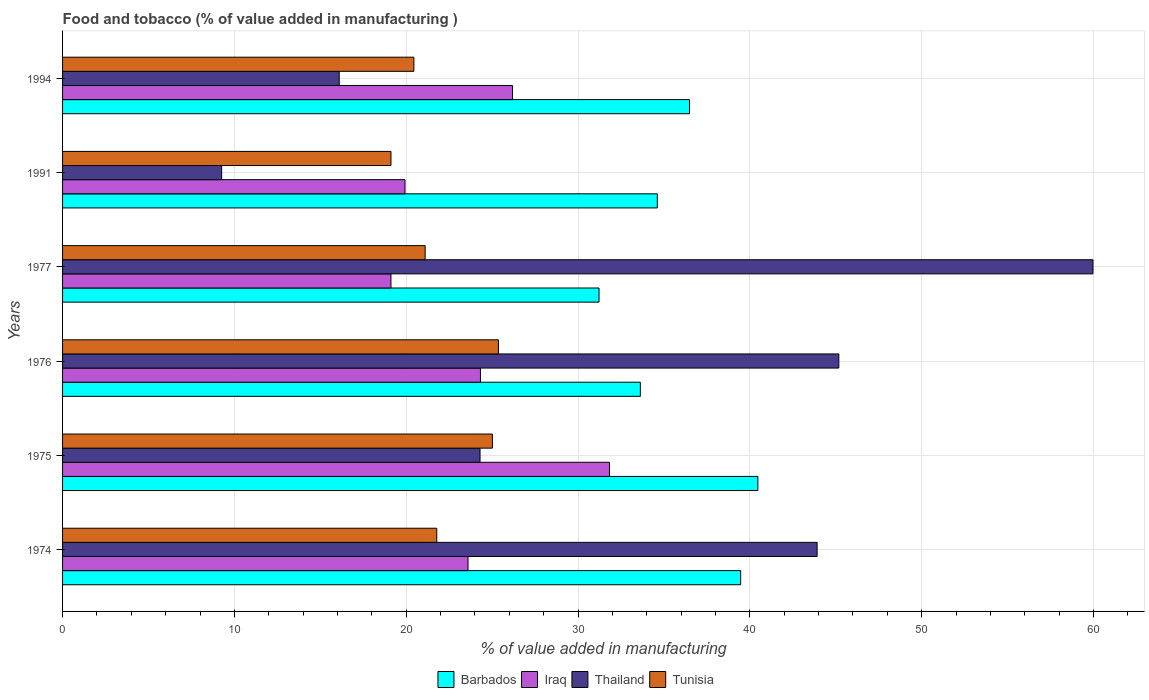How many groups of bars are there?
Offer a very short reply. 6. Are the number of bars per tick equal to the number of legend labels?
Give a very brief answer. Yes. How many bars are there on the 2nd tick from the bottom?
Ensure brevity in your answer.  4. In how many cases, is the number of bars for a given year not equal to the number of legend labels?
Ensure brevity in your answer.  0. What is the value added in manufacturing food and tobacco in Thailand in 1974?
Provide a short and direct response. 43.91. Across all years, what is the maximum value added in manufacturing food and tobacco in Tunisia?
Give a very brief answer. 25.37. Across all years, what is the minimum value added in manufacturing food and tobacco in Iraq?
Your answer should be compact. 19.11. In which year was the value added in manufacturing food and tobacco in Iraq maximum?
Provide a short and direct response. 1975. What is the total value added in manufacturing food and tobacco in Barbados in the graph?
Make the answer very short. 215.87. What is the difference between the value added in manufacturing food and tobacco in Iraq in 1976 and that in 1977?
Offer a terse response. 5.21. What is the difference between the value added in manufacturing food and tobacco in Tunisia in 1976 and the value added in manufacturing food and tobacco in Iraq in 1974?
Offer a terse response. 1.77. What is the average value added in manufacturing food and tobacco in Tunisia per year?
Your answer should be compact. 22.14. In the year 1976, what is the difference between the value added in manufacturing food and tobacco in Tunisia and value added in manufacturing food and tobacco in Thailand?
Provide a short and direct response. -19.81. In how many years, is the value added in manufacturing food and tobacco in Thailand greater than 8 %?
Ensure brevity in your answer.  6. What is the ratio of the value added in manufacturing food and tobacco in Iraq in 1976 to that in 1994?
Ensure brevity in your answer.  0.93. Is the value added in manufacturing food and tobacco in Thailand in 1974 less than that in 1991?
Provide a succinct answer. No. What is the difference between the highest and the second highest value added in manufacturing food and tobacco in Iraq?
Make the answer very short. 5.65. What is the difference between the highest and the lowest value added in manufacturing food and tobacco in Iraq?
Provide a succinct answer. 12.72. In how many years, is the value added in manufacturing food and tobacco in Thailand greater than the average value added in manufacturing food and tobacco in Thailand taken over all years?
Your answer should be very brief. 3. What does the 4th bar from the top in 1977 represents?
Make the answer very short. Barbados. What does the 2nd bar from the bottom in 1974 represents?
Make the answer very short. Iraq. How many years are there in the graph?
Your answer should be compact. 6. What is the difference between two consecutive major ticks on the X-axis?
Your answer should be compact. 10. Are the values on the major ticks of X-axis written in scientific E-notation?
Your answer should be compact. No. Does the graph contain any zero values?
Provide a short and direct response. No. Where does the legend appear in the graph?
Make the answer very short. Bottom center. What is the title of the graph?
Give a very brief answer. Food and tobacco (% of value added in manufacturing ). What is the label or title of the X-axis?
Offer a terse response. % of value added in manufacturing. What is the label or title of the Y-axis?
Give a very brief answer. Years. What is the % of value added in manufacturing in Barbados in 1974?
Keep it short and to the point. 39.46. What is the % of value added in manufacturing of Iraq in 1974?
Your answer should be compact. 23.6. What is the % of value added in manufacturing of Thailand in 1974?
Make the answer very short. 43.91. What is the % of value added in manufacturing of Tunisia in 1974?
Make the answer very short. 21.78. What is the % of value added in manufacturing of Barbados in 1975?
Your answer should be compact. 40.46. What is the % of value added in manufacturing in Iraq in 1975?
Provide a succinct answer. 31.83. What is the % of value added in manufacturing in Thailand in 1975?
Provide a succinct answer. 24.3. What is the % of value added in manufacturing of Tunisia in 1975?
Your answer should be very brief. 25.01. What is the % of value added in manufacturing in Barbados in 1976?
Provide a succinct answer. 33.63. What is the % of value added in manufacturing in Iraq in 1976?
Ensure brevity in your answer.  24.32. What is the % of value added in manufacturing of Thailand in 1976?
Give a very brief answer. 45.17. What is the % of value added in manufacturing in Tunisia in 1976?
Give a very brief answer. 25.37. What is the % of value added in manufacturing of Barbados in 1977?
Provide a succinct answer. 31.22. What is the % of value added in manufacturing of Iraq in 1977?
Your answer should be compact. 19.11. What is the % of value added in manufacturing of Thailand in 1977?
Your answer should be very brief. 59.97. What is the % of value added in manufacturing in Tunisia in 1977?
Keep it short and to the point. 21.1. What is the % of value added in manufacturing in Barbados in 1991?
Give a very brief answer. 34.61. What is the % of value added in manufacturing in Iraq in 1991?
Provide a short and direct response. 19.93. What is the % of value added in manufacturing of Thailand in 1991?
Keep it short and to the point. 9.26. What is the % of value added in manufacturing in Tunisia in 1991?
Keep it short and to the point. 19.11. What is the % of value added in manufacturing of Barbados in 1994?
Give a very brief answer. 36.49. What is the % of value added in manufacturing in Iraq in 1994?
Your answer should be very brief. 26.19. What is the % of value added in manufacturing in Thailand in 1994?
Give a very brief answer. 16.1. What is the % of value added in manufacturing in Tunisia in 1994?
Provide a succinct answer. 20.45. Across all years, what is the maximum % of value added in manufacturing in Barbados?
Provide a short and direct response. 40.46. Across all years, what is the maximum % of value added in manufacturing in Iraq?
Make the answer very short. 31.83. Across all years, what is the maximum % of value added in manufacturing in Thailand?
Ensure brevity in your answer.  59.97. Across all years, what is the maximum % of value added in manufacturing of Tunisia?
Provide a short and direct response. 25.37. Across all years, what is the minimum % of value added in manufacturing in Barbados?
Your answer should be compact. 31.22. Across all years, what is the minimum % of value added in manufacturing in Iraq?
Your answer should be compact. 19.11. Across all years, what is the minimum % of value added in manufacturing of Thailand?
Provide a short and direct response. 9.26. Across all years, what is the minimum % of value added in manufacturing in Tunisia?
Your answer should be compact. 19.11. What is the total % of value added in manufacturing in Barbados in the graph?
Your answer should be compact. 215.87. What is the total % of value added in manufacturing of Iraq in the graph?
Your answer should be very brief. 144.97. What is the total % of value added in manufacturing in Thailand in the graph?
Make the answer very short. 198.71. What is the total % of value added in manufacturing in Tunisia in the graph?
Offer a very short reply. 132.82. What is the difference between the % of value added in manufacturing in Barbados in 1974 and that in 1975?
Provide a succinct answer. -1. What is the difference between the % of value added in manufacturing in Iraq in 1974 and that in 1975?
Give a very brief answer. -8.24. What is the difference between the % of value added in manufacturing of Thailand in 1974 and that in 1975?
Your answer should be compact. 19.62. What is the difference between the % of value added in manufacturing in Tunisia in 1974 and that in 1975?
Provide a succinct answer. -3.24. What is the difference between the % of value added in manufacturing in Barbados in 1974 and that in 1976?
Provide a succinct answer. 5.84. What is the difference between the % of value added in manufacturing of Iraq in 1974 and that in 1976?
Offer a terse response. -0.72. What is the difference between the % of value added in manufacturing in Thailand in 1974 and that in 1976?
Provide a succinct answer. -1.26. What is the difference between the % of value added in manufacturing in Tunisia in 1974 and that in 1976?
Provide a succinct answer. -3.59. What is the difference between the % of value added in manufacturing of Barbados in 1974 and that in 1977?
Keep it short and to the point. 8.24. What is the difference between the % of value added in manufacturing in Iraq in 1974 and that in 1977?
Provide a succinct answer. 4.49. What is the difference between the % of value added in manufacturing in Thailand in 1974 and that in 1977?
Ensure brevity in your answer.  -16.05. What is the difference between the % of value added in manufacturing of Tunisia in 1974 and that in 1977?
Your answer should be very brief. 0.68. What is the difference between the % of value added in manufacturing of Barbados in 1974 and that in 1991?
Ensure brevity in your answer.  4.85. What is the difference between the % of value added in manufacturing in Iraq in 1974 and that in 1991?
Give a very brief answer. 3.67. What is the difference between the % of value added in manufacturing of Thailand in 1974 and that in 1991?
Make the answer very short. 34.65. What is the difference between the % of value added in manufacturing in Tunisia in 1974 and that in 1991?
Make the answer very short. 2.66. What is the difference between the % of value added in manufacturing in Barbados in 1974 and that in 1994?
Provide a succinct answer. 2.98. What is the difference between the % of value added in manufacturing of Iraq in 1974 and that in 1994?
Offer a very short reply. -2.59. What is the difference between the % of value added in manufacturing of Thailand in 1974 and that in 1994?
Give a very brief answer. 27.81. What is the difference between the % of value added in manufacturing in Tunisia in 1974 and that in 1994?
Give a very brief answer. 1.33. What is the difference between the % of value added in manufacturing in Barbados in 1975 and that in 1976?
Your answer should be very brief. 6.84. What is the difference between the % of value added in manufacturing of Iraq in 1975 and that in 1976?
Ensure brevity in your answer.  7.51. What is the difference between the % of value added in manufacturing in Thailand in 1975 and that in 1976?
Offer a terse response. -20.88. What is the difference between the % of value added in manufacturing of Tunisia in 1975 and that in 1976?
Keep it short and to the point. -0.35. What is the difference between the % of value added in manufacturing of Barbados in 1975 and that in 1977?
Keep it short and to the point. 9.24. What is the difference between the % of value added in manufacturing in Iraq in 1975 and that in 1977?
Provide a short and direct response. 12.72. What is the difference between the % of value added in manufacturing in Thailand in 1975 and that in 1977?
Make the answer very short. -35.67. What is the difference between the % of value added in manufacturing of Tunisia in 1975 and that in 1977?
Provide a succinct answer. 3.91. What is the difference between the % of value added in manufacturing in Barbados in 1975 and that in 1991?
Provide a short and direct response. 5.85. What is the difference between the % of value added in manufacturing in Iraq in 1975 and that in 1991?
Your answer should be compact. 11.9. What is the difference between the % of value added in manufacturing in Thailand in 1975 and that in 1991?
Provide a short and direct response. 15.04. What is the difference between the % of value added in manufacturing of Tunisia in 1975 and that in 1991?
Offer a very short reply. 5.9. What is the difference between the % of value added in manufacturing in Barbados in 1975 and that in 1994?
Provide a short and direct response. 3.98. What is the difference between the % of value added in manufacturing in Iraq in 1975 and that in 1994?
Offer a terse response. 5.65. What is the difference between the % of value added in manufacturing of Thailand in 1975 and that in 1994?
Your answer should be compact. 8.19. What is the difference between the % of value added in manufacturing in Tunisia in 1975 and that in 1994?
Keep it short and to the point. 4.57. What is the difference between the % of value added in manufacturing of Barbados in 1976 and that in 1977?
Give a very brief answer. 2.41. What is the difference between the % of value added in manufacturing in Iraq in 1976 and that in 1977?
Offer a terse response. 5.21. What is the difference between the % of value added in manufacturing in Thailand in 1976 and that in 1977?
Provide a short and direct response. -14.79. What is the difference between the % of value added in manufacturing in Tunisia in 1976 and that in 1977?
Provide a succinct answer. 4.26. What is the difference between the % of value added in manufacturing in Barbados in 1976 and that in 1991?
Your answer should be compact. -0.99. What is the difference between the % of value added in manufacturing in Iraq in 1976 and that in 1991?
Make the answer very short. 4.39. What is the difference between the % of value added in manufacturing in Thailand in 1976 and that in 1991?
Your response must be concise. 35.92. What is the difference between the % of value added in manufacturing in Tunisia in 1976 and that in 1991?
Make the answer very short. 6.25. What is the difference between the % of value added in manufacturing in Barbados in 1976 and that in 1994?
Offer a terse response. -2.86. What is the difference between the % of value added in manufacturing of Iraq in 1976 and that in 1994?
Your answer should be very brief. -1.87. What is the difference between the % of value added in manufacturing in Thailand in 1976 and that in 1994?
Ensure brevity in your answer.  29.07. What is the difference between the % of value added in manufacturing of Tunisia in 1976 and that in 1994?
Keep it short and to the point. 4.92. What is the difference between the % of value added in manufacturing of Barbados in 1977 and that in 1991?
Give a very brief answer. -3.39. What is the difference between the % of value added in manufacturing of Iraq in 1977 and that in 1991?
Offer a terse response. -0.82. What is the difference between the % of value added in manufacturing in Thailand in 1977 and that in 1991?
Your response must be concise. 50.71. What is the difference between the % of value added in manufacturing of Tunisia in 1977 and that in 1991?
Provide a succinct answer. 1.99. What is the difference between the % of value added in manufacturing in Barbados in 1977 and that in 1994?
Give a very brief answer. -5.27. What is the difference between the % of value added in manufacturing of Iraq in 1977 and that in 1994?
Your answer should be very brief. -7.08. What is the difference between the % of value added in manufacturing of Thailand in 1977 and that in 1994?
Provide a succinct answer. 43.87. What is the difference between the % of value added in manufacturing in Tunisia in 1977 and that in 1994?
Provide a short and direct response. 0.66. What is the difference between the % of value added in manufacturing in Barbados in 1991 and that in 1994?
Give a very brief answer. -1.87. What is the difference between the % of value added in manufacturing of Iraq in 1991 and that in 1994?
Give a very brief answer. -6.26. What is the difference between the % of value added in manufacturing of Thailand in 1991 and that in 1994?
Keep it short and to the point. -6.84. What is the difference between the % of value added in manufacturing of Tunisia in 1991 and that in 1994?
Give a very brief answer. -1.33. What is the difference between the % of value added in manufacturing of Barbados in 1974 and the % of value added in manufacturing of Iraq in 1975?
Your response must be concise. 7.63. What is the difference between the % of value added in manufacturing of Barbados in 1974 and the % of value added in manufacturing of Thailand in 1975?
Keep it short and to the point. 15.17. What is the difference between the % of value added in manufacturing of Barbados in 1974 and the % of value added in manufacturing of Tunisia in 1975?
Your answer should be compact. 14.45. What is the difference between the % of value added in manufacturing of Iraq in 1974 and the % of value added in manufacturing of Thailand in 1975?
Make the answer very short. -0.7. What is the difference between the % of value added in manufacturing of Iraq in 1974 and the % of value added in manufacturing of Tunisia in 1975?
Your answer should be compact. -1.42. What is the difference between the % of value added in manufacturing in Thailand in 1974 and the % of value added in manufacturing in Tunisia in 1975?
Your answer should be compact. 18.9. What is the difference between the % of value added in manufacturing of Barbados in 1974 and the % of value added in manufacturing of Iraq in 1976?
Your answer should be compact. 15.14. What is the difference between the % of value added in manufacturing of Barbados in 1974 and the % of value added in manufacturing of Thailand in 1976?
Give a very brief answer. -5.71. What is the difference between the % of value added in manufacturing of Barbados in 1974 and the % of value added in manufacturing of Tunisia in 1976?
Offer a very short reply. 14.1. What is the difference between the % of value added in manufacturing in Iraq in 1974 and the % of value added in manufacturing in Thailand in 1976?
Keep it short and to the point. -21.58. What is the difference between the % of value added in manufacturing of Iraq in 1974 and the % of value added in manufacturing of Tunisia in 1976?
Your answer should be compact. -1.77. What is the difference between the % of value added in manufacturing in Thailand in 1974 and the % of value added in manufacturing in Tunisia in 1976?
Offer a very short reply. 18.55. What is the difference between the % of value added in manufacturing of Barbados in 1974 and the % of value added in manufacturing of Iraq in 1977?
Ensure brevity in your answer.  20.35. What is the difference between the % of value added in manufacturing in Barbados in 1974 and the % of value added in manufacturing in Thailand in 1977?
Your answer should be very brief. -20.5. What is the difference between the % of value added in manufacturing of Barbados in 1974 and the % of value added in manufacturing of Tunisia in 1977?
Give a very brief answer. 18.36. What is the difference between the % of value added in manufacturing of Iraq in 1974 and the % of value added in manufacturing of Thailand in 1977?
Make the answer very short. -36.37. What is the difference between the % of value added in manufacturing of Iraq in 1974 and the % of value added in manufacturing of Tunisia in 1977?
Your response must be concise. 2.5. What is the difference between the % of value added in manufacturing of Thailand in 1974 and the % of value added in manufacturing of Tunisia in 1977?
Make the answer very short. 22.81. What is the difference between the % of value added in manufacturing in Barbados in 1974 and the % of value added in manufacturing in Iraq in 1991?
Provide a short and direct response. 19.53. What is the difference between the % of value added in manufacturing of Barbados in 1974 and the % of value added in manufacturing of Thailand in 1991?
Provide a short and direct response. 30.2. What is the difference between the % of value added in manufacturing of Barbados in 1974 and the % of value added in manufacturing of Tunisia in 1991?
Your response must be concise. 20.35. What is the difference between the % of value added in manufacturing in Iraq in 1974 and the % of value added in manufacturing in Thailand in 1991?
Your response must be concise. 14.34. What is the difference between the % of value added in manufacturing in Iraq in 1974 and the % of value added in manufacturing in Tunisia in 1991?
Ensure brevity in your answer.  4.48. What is the difference between the % of value added in manufacturing in Thailand in 1974 and the % of value added in manufacturing in Tunisia in 1991?
Offer a terse response. 24.8. What is the difference between the % of value added in manufacturing in Barbados in 1974 and the % of value added in manufacturing in Iraq in 1994?
Your response must be concise. 13.28. What is the difference between the % of value added in manufacturing in Barbados in 1974 and the % of value added in manufacturing in Thailand in 1994?
Provide a short and direct response. 23.36. What is the difference between the % of value added in manufacturing of Barbados in 1974 and the % of value added in manufacturing of Tunisia in 1994?
Provide a short and direct response. 19.02. What is the difference between the % of value added in manufacturing in Iraq in 1974 and the % of value added in manufacturing in Thailand in 1994?
Your answer should be compact. 7.5. What is the difference between the % of value added in manufacturing of Iraq in 1974 and the % of value added in manufacturing of Tunisia in 1994?
Your answer should be very brief. 3.15. What is the difference between the % of value added in manufacturing in Thailand in 1974 and the % of value added in manufacturing in Tunisia in 1994?
Offer a terse response. 23.47. What is the difference between the % of value added in manufacturing in Barbados in 1975 and the % of value added in manufacturing in Iraq in 1976?
Provide a short and direct response. 16.14. What is the difference between the % of value added in manufacturing in Barbados in 1975 and the % of value added in manufacturing in Thailand in 1976?
Provide a succinct answer. -4.71. What is the difference between the % of value added in manufacturing in Barbados in 1975 and the % of value added in manufacturing in Tunisia in 1976?
Make the answer very short. 15.1. What is the difference between the % of value added in manufacturing in Iraq in 1975 and the % of value added in manufacturing in Thailand in 1976?
Your response must be concise. -13.34. What is the difference between the % of value added in manufacturing of Iraq in 1975 and the % of value added in manufacturing of Tunisia in 1976?
Ensure brevity in your answer.  6.47. What is the difference between the % of value added in manufacturing of Thailand in 1975 and the % of value added in manufacturing of Tunisia in 1976?
Offer a very short reply. -1.07. What is the difference between the % of value added in manufacturing of Barbados in 1975 and the % of value added in manufacturing of Iraq in 1977?
Provide a short and direct response. 21.35. What is the difference between the % of value added in manufacturing in Barbados in 1975 and the % of value added in manufacturing in Thailand in 1977?
Provide a succinct answer. -19.5. What is the difference between the % of value added in manufacturing of Barbados in 1975 and the % of value added in manufacturing of Tunisia in 1977?
Provide a succinct answer. 19.36. What is the difference between the % of value added in manufacturing in Iraq in 1975 and the % of value added in manufacturing in Thailand in 1977?
Offer a terse response. -28.13. What is the difference between the % of value added in manufacturing in Iraq in 1975 and the % of value added in manufacturing in Tunisia in 1977?
Give a very brief answer. 10.73. What is the difference between the % of value added in manufacturing of Thailand in 1975 and the % of value added in manufacturing of Tunisia in 1977?
Offer a very short reply. 3.19. What is the difference between the % of value added in manufacturing in Barbados in 1975 and the % of value added in manufacturing in Iraq in 1991?
Your answer should be compact. 20.54. What is the difference between the % of value added in manufacturing in Barbados in 1975 and the % of value added in manufacturing in Thailand in 1991?
Give a very brief answer. 31.21. What is the difference between the % of value added in manufacturing of Barbados in 1975 and the % of value added in manufacturing of Tunisia in 1991?
Your response must be concise. 21.35. What is the difference between the % of value added in manufacturing in Iraq in 1975 and the % of value added in manufacturing in Thailand in 1991?
Your response must be concise. 22.57. What is the difference between the % of value added in manufacturing of Iraq in 1975 and the % of value added in manufacturing of Tunisia in 1991?
Give a very brief answer. 12.72. What is the difference between the % of value added in manufacturing in Thailand in 1975 and the % of value added in manufacturing in Tunisia in 1991?
Your response must be concise. 5.18. What is the difference between the % of value added in manufacturing of Barbados in 1975 and the % of value added in manufacturing of Iraq in 1994?
Your answer should be very brief. 14.28. What is the difference between the % of value added in manufacturing in Barbados in 1975 and the % of value added in manufacturing in Thailand in 1994?
Provide a succinct answer. 24.36. What is the difference between the % of value added in manufacturing of Barbados in 1975 and the % of value added in manufacturing of Tunisia in 1994?
Offer a terse response. 20.02. What is the difference between the % of value added in manufacturing in Iraq in 1975 and the % of value added in manufacturing in Thailand in 1994?
Make the answer very short. 15.73. What is the difference between the % of value added in manufacturing of Iraq in 1975 and the % of value added in manufacturing of Tunisia in 1994?
Your answer should be very brief. 11.39. What is the difference between the % of value added in manufacturing in Thailand in 1975 and the % of value added in manufacturing in Tunisia in 1994?
Give a very brief answer. 3.85. What is the difference between the % of value added in manufacturing in Barbados in 1976 and the % of value added in manufacturing in Iraq in 1977?
Your response must be concise. 14.51. What is the difference between the % of value added in manufacturing in Barbados in 1976 and the % of value added in manufacturing in Thailand in 1977?
Give a very brief answer. -26.34. What is the difference between the % of value added in manufacturing of Barbados in 1976 and the % of value added in manufacturing of Tunisia in 1977?
Your answer should be compact. 12.52. What is the difference between the % of value added in manufacturing in Iraq in 1976 and the % of value added in manufacturing in Thailand in 1977?
Give a very brief answer. -35.65. What is the difference between the % of value added in manufacturing in Iraq in 1976 and the % of value added in manufacturing in Tunisia in 1977?
Ensure brevity in your answer.  3.22. What is the difference between the % of value added in manufacturing of Thailand in 1976 and the % of value added in manufacturing of Tunisia in 1977?
Your answer should be compact. 24.07. What is the difference between the % of value added in manufacturing of Barbados in 1976 and the % of value added in manufacturing of Iraq in 1991?
Offer a terse response. 13.7. What is the difference between the % of value added in manufacturing in Barbados in 1976 and the % of value added in manufacturing in Thailand in 1991?
Offer a very short reply. 24.37. What is the difference between the % of value added in manufacturing of Barbados in 1976 and the % of value added in manufacturing of Tunisia in 1991?
Give a very brief answer. 14.51. What is the difference between the % of value added in manufacturing in Iraq in 1976 and the % of value added in manufacturing in Thailand in 1991?
Provide a short and direct response. 15.06. What is the difference between the % of value added in manufacturing of Iraq in 1976 and the % of value added in manufacturing of Tunisia in 1991?
Your answer should be very brief. 5.21. What is the difference between the % of value added in manufacturing in Thailand in 1976 and the % of value added in manufacturing in Tunisia in 1991?
Provide a succinct answer. 26.06. What is the difference between the % of value added in manufacturing in Barbados in 1976 and the % of value added in manufacturing in Iraq in 1994?
Ensure brevity in your answer.  7.44. What is the difference between the % of value added in manufacturing of Barbados in 1976 and the % of value added in manufacturing of Thailand in 1994?
Provide a short and direct response. 17.52. What is the difference between the % of value added in manufacturing of Barbados in 1976 and the % of value added in manufacturing of Tunisia in 1994?
Ensure brevity in your answer.  13.18. What is the difference between the % of value added in manufacturing in Iraq in 1976 and the % of value added in manufacturing in Thailand in 1994?
Your answer should be very brief. 8.22. What is the difference between the % of value added in manufacturing of Iraq in 1976 and the % of value added in manufacturing of Tunisia in 1994?
Your answer should be compact. 3.87. What is the difference between the % of value added in manufacturing of Thailand in 1976 and the % of value added in manufacturing of Tunisia in 1994?
Keep it short and to the point. 24.73. What is the difference between the % of value added in manufacturing in Barbados in 1977 and the % of value added in manufacturing in Iraq in 1991?
Your answer should be very brief. 11.29. What is the difference between the % of value added in manufacturing of Barbados in 1977 and the % of value added in manufacturing of Thailand in 1991?
Offer a terse response. 21.96. What is the difference between the % of value added in manufacturing in Barbados in 1977 and the % of value added in manufacturing in Tunisia in 1991?
Your answer should be very brief. 12.11. What is the difference between the % of value added in manufacturing of Iraq in 1977 and the % of value added in manufacturing of Thailand in 1991?
Ensure brevity in your answer.  9.85. What is the difference between the % of value added in manufacturing of Iraq in 1977 and the % of value added in manufacturing of Tunisia in 1991?
Make the answer very short. -0. What is the difference between the % of value added in manufacturing in Thailand in 1977 and the % of value added in manufacturing in Tunisia in 1991?
Your answer should be very brief. 40.85. What is the difference between the % of value added in manufacturing in Barbados in 1977 and the % of value added in manufacturing in Iraq in 1994?
Make the answer very short. 5.03. What is the difference between the % of value added in manufacturing in Barbados in 1977 and the % of value added in manufacturing in Thailand in 1994?
Provide a succinct answer. 15.12. What is the difference between the % of value added in manufacturing in Barbados in 1977 and the % of value added in manufacturing in Tunisia in 1994?
Offer a terse response. 10.78. What is the difference between the % of value added in manufacturing of Iraq in 1977 and the % of value added in manufacturing of Thailand in 1994?
Offer a terse response. 3.01. What is the difference between the % of value added in manufacturing of Iraq in 1977 and the % of value added in manufacturing of Tunisia in 1994?
Give a very brief answer. -1.33. What is the difference between the % of value added in manufacturing in Thailand in 1977 and the % of value added in manufacturing in Tunisia in 1994?
Ensure brevity in your answer.  39.52. What is the difference between the % of value added in manufacturing in Barbados in 1991 and the % of value added in manufacturing in Iraq in 1994?
Your response must be concise. 8.43. What is the difference between the % of value added in manufacturing of Barbados in 1991 and the % of value added in manufacturing of Thailand in 1994?
Ensure brevity in your answer.  18.51. What is the difference between the % of value added in manufacturing of Barbados in 1991 and the % of value added in manufacturing of Tunisia in 1994?
Your response must be concise. 14.17. What is the difference between the % of value added in manufacturing in Iraq in 1991 and the % of value added in manufacturing in Thailand in 1994?
Your response must be concise. 3.83. What is the difference between the % of value added in manufacturing of Iraq in 1991 and the % of value added in manufacturing of Tunisia in 1994?
Offer a terse response. -0.52. What is the difference between the % of value added in manufacturing of Thailand in 1991 and the % of value added in manufacturing of Tunisia in 1994?
Make the answer very short. -11.19. What is the average % of value added in manufacturing of Barbados per year?
Your answer should be very brief. 35.98. What is the average % of value added in manufacturing in Iraq per year?
Your answer should be compact. 24.16. What is the average % of value added in manufacturing of Thailand per year?
Offer a terse response. 33.12. What is the average % of value added in manufacturing of Tunisia per year?
Make the answer very short. 22.14. In the year 1974, what is the difference between the % of value added in manufacturing in Barbados and % of value added in manufacturing in Iraq?
Offer a terse response. 15.87. In the year 1974, what is the difference between the % of value added in manufacturing in Barbados and % of value added in manufacturing in Thailand?
Offer a terse response. -4.45. In the year 1974, what is the difference between the % of value added in manufacturing of Barbados and % of value added in manufacturing of Tunisia?
Your answer should be compact. 17.69. In the year 1974, what is the difference between the % of value added in manufacturing of Iraq and % of value added in manufacturing of Thailand?
Keep it short and to the point. -20.32. In the year 1974, what is the difference between the % of value added in manufacturing of Iraq and % of value added in manufacturing of Tunisia?
Give a very brief answer. 1.82. In the year 1974, what is the difference between the % of value added in manufacturing of Thailand and % of value added in manufacturing of Tunisia?
Offer a very short reply. 22.13. In the year 1975, what is the difference between the % of value added in manufacturing of Barbados and % of value added in manufacturing of Iraq?
Make the answer very short. 8.63. In the year 1975, what is the difference between the % of value added in manufacturing in Barbados and % of value added in manufacturing in Thailand?
Give a very brief answer. 16.17. In the year 1975, what is the difference between the % of value added in manufacturing in Barbados and % of value added in manufacturing in Tunisia?
Your response must be concise. 15.45. In the year 1975, what is the difference between the % of value added in manufacturing of Iraq and % of value added in manufacturing of Thailand?
Provide a succinct answer. 7.54. In the year 1975, what is the difference between the % of value added in manufacturing of Iraq and % of value added in manufacturing of Tunisia?
Offer a very short reply. 6.82. In the year 1975, what is the difference between the % of value added in manufacturing in Thailand and % of value added in manufacturing in Tunisia?
Provide a short and direct response. -0.72. In the year 1976, what is the difference between the % of value added in manufacturing of Barbados and % of value added in manufacturing of Iraq?
Keep it short and to the point. 9.31. In the year 1976, what is the difference between the % of value added in manufacturing in Barbados and % of value added in manufacturing in Thailand?
Your answer should be compact. -11.55. In the year 1976, what is the difference between the % of value added in manufacturing in Barbados and % of value added in manufacturing in Tunisia?
Keep it short and to the point. 8.26. In the year 1976, what is the difference between the % of value added in manufacturing in Iraq and % of value added in manufacturing in Thailand?
Ensure brevity in your answer.  -20.86. In the year 1976, what is the difference between the % of value added in manufacturing of Iraq and % of value added in manufacturing of Tunisia?
Your answer should be very brief. -1.05. In the year 1976, what is the difference between the % of value added in manufacturing of Thailand and % of value added in manufacturing of Tunisia?
Make the answer very short. 19.81. In the year 1977, what is the difference between the % of value added in manufacturing of Barbados and % of value added in manufacturing of Iraq?
Your response must be concise. 12.11. In the year 1977, what is the difference between the % of value added in manufacturing in Barbados and % of value added in manufacturing in Thailand?
Offer a very short reply. -28.75. In the year 1977, what is the difference between the % of value added in manufacturing of Barbados and % of value added in manufacturing of Tunisia?
Make the answer very short. 10.12. In the year 1977, what is the difference between the % of value added in manufacturing in Iraq and % of value added in manufacturing in Thailand?
Provide a short and direct response. -40.86. In the year 1977, what is the difference between the % of value added in manufacturing of Iraq and % of value added in manufacturing of Tunisia?
Keep it short and to the point. -1.99. In the year 1977, what is the difference between the % of value added in manufacturing in Thailand and % of value added in manufacturing in Tunisia?
Offer a very short reply. 38.86. In the year 1991, what is the difference between the % of value added in manufacturing in Barbados and % of value added in manufacturing in Iraq?
Ensure brevity in your answer.  14.69. In the year 1991, what is the difference between the % of value added in manufacturing in Barbados and % of value added in manufacturing in Thailand?
Ensure brevity in your answer.  25.36. In the year 1991, what is the difference between the % of value added in manufacturing in Barbados and % of value added in manufacturing in Tunisia?
Provide a succinct answer. 15.5. In the year 1991, what is the difference between the % of value added in manufacturing in Iraq and % of value added in manufacturing in Thailand?
Offer a very short reply. 10.67. In the year 1991, what is the difference between the % of value added in manufacturing in Iraq and % of value added in manufacturing in Tunisia?
Ensure brevity in your answer.  0.82. In the year 1991, what is the difference between the % of value added in manufacturing of Thailand and % of value added in manufacturing of Tunisia?
Provide a succinct answer. -9.85. In the year 1994, what is the difference between the % of value added in manufacturing of Barbados and % of value added in manufacturing of Iraq?
Give a very brief answer. 10.3. In the year 1994, what is the difference between the % of value added in manufacturing in Barbados and % of value added in manufacturing in Thailand?
Ensure brevity in your answer.  20.39. In the year 1994, what is the difference between the % of value added in manufacturing of Barbados and % of value added in manufacturing of Tunisia?
Your answer should be very brief. 16.04. In the year 1994, what is the difference between the % of value added in manufacturing in Iraq and % of value added in manufacturing in Thailand?
Provide a succinct answer. 10.09. In the year 1994, what is the difference between the % of value added in manufacturing in Iraq and % of value added in manufacturing in Tunisia?
Your response must be concise. 5.74. In the year 1994, what is the difference between the % of value added in manufacturing in Thailand and % of value added in manufacturing in Tunisia?
Offer a terse response. -4.34. What is the ratio of the % of value added in manufacturing in Barbados in 1974 to that in 1975?
Provide a short and direct response. 0.98. What is the ratio of the % of value added in manufacturing of Iraq in 1974 to that in 1975?
Give a very brief answer. 0.74. What is the ratio of the % of value added in manufacturing in Thailand in 1974 to that in 1975?
Make the answer very short. 1.81. What is the ratio of the % of value added in manufacturing of Tunisia in 1974 to that in 1975?
Give a very brief answer. 0.87. What is the ratio of the % of value added in manufacturing in Barbados in 1974 to that in 1976?
Make the answer very short. 1.17. What is the ratio of the % of value added in manufacturing in Iraq in 1974 to that in 1976?
Make the answer very short. 0.97. What is the ratio of the % of value added in manufacturing in Thailand in 1974 to that in 1976?
Give a very brief answer. 0.97. What is the ratio of the % of value added in manufacturing in Tunisia in 1974 to that in 1976?
Make the answer very short. 0.86. What is the ratio of the % of value added in manufacturing in Barbados in 1974 to that in 1977?
Ensure brevity in your answer.  1.26. What is the ratio of the % of value added in manufacturing in Iraq in 1974 to that in 1977?
Your answer should be compact. 1.23. What is the ratio of the % of value added in manufacturing of Thailand in 1974 to that in 1977?
Your answer should be compact. 0.73. What is the ratio of the % of value added in manufacturing in Tunisia in 1974 to that in 1977?
Provide a succinct answer. 1.03. What is the ratio of the % of value added in manufacturing of Barbados in 1974 to that in 1991?
Your answer should be compact. 1.14. What is the ratio of the % of value added in manufacturing of Iraq in 1974 to that in 1991?
Your answer should be very brief. 1.18. What is the ratio of the % of value added in manufacturing in Thailand in 1974 to that in 1991?
Your answer should be very brief. 4.74. What is the ratio of the % of value added in manufacturing in Tunisia in 1974 to that in 1991?
Your answer should be very brief. 1.14. What is the ratio of the % of value added in manufacturing in Barbados in 1974 to that in 1994?
Offer a very short reply. 1.08. What is the ratio of the % of value added in manufacturing of Iraq in 1974 to that in 1994?
Ensure brevity in your answer.  0.9. What is the ratio of the % of value added in manufacturing in Thailand in 1974 to that in 1994?
Your answer should be compact. 2.73. What is the ratio of the % of value added in manufacturing in Tunisia in 1974 to that in 1994?
Offer a very short reply. 1.07. What is the ratio of the % of value added in manufacturing in Barbados in 1975 to that in 1976?
Ensure brevity in your answer.  1.2. What is the ratio of the % of value added in manufacturing of Iraq in 1975 to that in 1976?
Your answer should be very brief. 1.31. What is the ratio of the % of value added in manufacturing in Thailand in 1975 to that in 1976?
Give a very brief answer. 0.54. What is the ratio of the % of value added in manufacturing in Tunisia in 1975 to that in 1976?
Give a very brief answer. 0.99. What is the ratio of the % of value added in manufacturing in Barbados in 1975 to that in 1977?
Your response must be concise. 1.3. What is the ratio of the % of value added in manufacturing of Iraq in 1975 to that in 1977?
Give a very brief answer. 1.67. What is the ratio of the % of value added in manufacturing of Thailand in 1975 to that in 1977?
Your answer should be very brief. 0.41. What is the ratio of the % of value added in manufacturing in Tunisia in 1975 to that in 1977?
Offer a terse response. 1.19. What is the ratio of the % of value added in manufacturing in Barbados in 1975 to that in 1991?
Provide a succinct answer. 1.17. What is the ratio of the % of value added in manufacturing in Iraq in 1975 to that in 1991?
Your response must be concise. 1.6. What is the ratio of the % of value added in manufacturing in Thailand in 1975 to that in 1991?
Provide a short and direct response. 2.62. What is the ratio of the % of value added in manufacturing of Tunisia in 1975 to that in 1991?
Provide a succinct answer. 1.31. What is the ratio of the % of value added in manufacturing in Barbados in 1975 to that in 1994?
Ensure brevity in your answer.  1.11. What is the ratio of the % of value added in manufacturing of Iraq in 1975 to that in 1994?
Offer a terse response. 1.22. What is the ratio of the % of value added in manufacturing in Thailand in 1975 to that in 1994?
Ensure brevity in your answer.  1.51. What is the ratio of the % of value added in manufacturing of Tunisia in 1975 to that in 1994?
Ensure brevity in your answer.  1.22. What is the ratio of the % of value added in manufacturing in Barbados in 1976 to that in 1977?
Your answer should be compact. 1.08. What is the ratio of the % of value added in manufacturing in Iraq in 1976 to that in 1977?
Your response must be concise. 1.27. What is the ratio of the % of value added in manufacturing of Thailand in 1976 to that in 1977?
Offer a very short reply. 0.75. What is the ratio of the % of value added in manufacturing of Tunisia in 1976 to that in 1977?
Offer a terse response. 1.2. What is the ratio of the % of value added in manufacturing of Barbados in 1976 to that in 1991?
Your response must be concise. 0.97. What is the ratio of the % of value added in manufacturing in Iraq in 1976 to that in 1991?
Offer a terse response. 1.22. What is the ratio of the % of value added in manufacturing of Thailand in 1976 to that in 1991?
Give a very brief answer. 4.88. What is the ratio of the % of value added in manufacturing in Tunisia in 1976 to that in 1991?
Keep it short and to the point. 1.33. What is the ratio of the % of value added in manufacturing of Barbados in 1976 to that in 1994?
Offer a terse response. 0.92. What is the ratio of the % of value added in manufacturing of Iraq in 1976 to that in 1994?
Provide a succinct answer. 0.93. What is the ratio of the % of value added in manufacturing in Thailand in 1976 to that in 1994?
Provide a succinct answer. 2.81. What is the ratio of the % of value added in manufacturing of Tunisia in 1976 to that in 1994?
Your answer should be very brief. 1.24. What is the ratio of the % of value added in manufacturing in Barbados in 1977 to that in 1991?
Make the answer very short. 0.9. What is the ratio of the % of value added in manufacturing in Thailand in 1977 to that in 1991?
Offer a very short reply. 6.48. What is the ratio of the % of value added in manufacturing in Tunisia in 1977 to that in 1991?
Offer a terse response. 1.1. What is the ratio of the % of value added in manufacturing in Barbados in 1977 to that in 1994?
Offer a very short reply. 0.86. What is the ratio of the % of value added in manufacturing in Iraq in 1977 to that in 1994?
Ensure brevity in your answer.  0.73. What is the ratio of the % of value added in manufacturing of Thailand in 1977 to that in 1994?
Offer a very short reply. 3.72. What is the ratio of the % of value added in manufacturing of Tunisia in 1977 to that in 1994?
Keep it short and to the point. 1.03. What is the ratio of the % of value added in manufacturing in Barbados in 1991 to that in 1994?
Offer a terse response. 0.95. What is the ratio of the % of value added in manufacturing in Iraq in 1991 to that in 1994?
Provide a succinct answer. 0.76. What is the ratio of the % of value added in manufacturing in Thailand in 1991 to that in 1994?
Make the answer very short. 0.57. What is the ratio of the % of value added in manufacturing of Tunisia in 1991 to that in 1994?
Give a very brief answer. 0.93. What is the difference between the highest and the second highest % of value added in manufacturing in Iraq?
Provide a short and direct response. 5.65. What is the difference between the highest and the second highest % of value added in manufacturing in Thailand?
Your answer should be compact. 14.79. What is the difference between the highest and the second highest % of value added in manufacturing in Tunisia?
Provide a succinct answer. 0.35. What is the difference between the highest and the lowest % of value added in manufacturing in Barbados?
Keep it short and to the point. 9.24. What is the difference between the highest and the lowest % of value added in manufacturing of Iraq?
Your answer should be compact. 12.72. What is the difference between the highest and the lowest % of value added in manufacturing in Thailand?
Your answer should be very brief. 50.71. What is the difference between the highest and the lowest % of value added in manufacturing of Tunisia?
Offer a terse response. 6.25. 